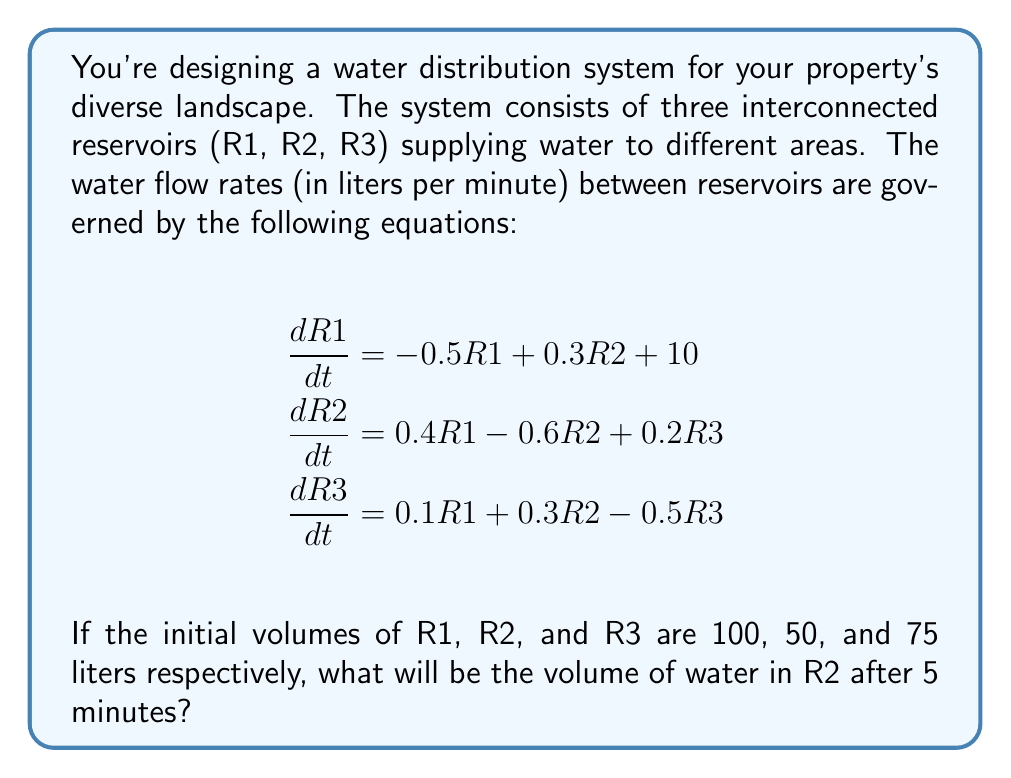Show me your answer to this math problem. To solve this problem, we need to use numerical methods to approximate the solution of the system of differential equations. We'll use the Euler method with a small time step.

Step 1: Set up the initial conditions and parameters
- Initial volumes: R1 = 100 L, R2 = 50 L, R3 = 75 L
- Time to simulate: t = 5 minutes
- Time step: Δt = 0.1 minutes (small step for better accuracy)

Step 2: Implement the Euler method
For each time step:
$$\begin{align}
R1_{new} &= R1 + (-0.5R1 + 0.3R2 + 10) \cdot \Delta t \\
R2_{new} &= R2 + (0.4R1 - 0.6R2 + 0.2R3) \cdot \Delta t \\
R3_{new} &= R3 + (0.1R1 + 0.3R2 - 0.5R3) \cdot \Delta t
\end{align}$$

Step 3: Iterate the calculations
We need to perform 50 iterations (5 minutes / 0.1 minutes per step)

Here's a Python code snippet to perform the calculations:

```python
import numpy as np

R1, R2, R3 = 100, 50, 75
dt = 0.1
t = np.arange(0, 5 + dt, dt)

for _ in range(len(t) - 1):
    dR1 = (-0.5 * R1 + 0.3 * R2 + 10) * dt
    dR2 = (0.4 * R1 - 0.6 * R2 + 0.2 * R3) * dt
    dR3 = (0.1 * R1 + 0.3 * R2 - 0.5 * R3) * dt
    
    R1 += dR1
    R2 += dR2
    R3 += dR3

print(f"R2 after 5 minutes: {R2:.2f} liters")
```

Step 4: Interpret the results
After running the simulation, we find that the volume of water in R2 after 5 minutes is approximately 61.84 liters.
Answer: 61.84 liters 